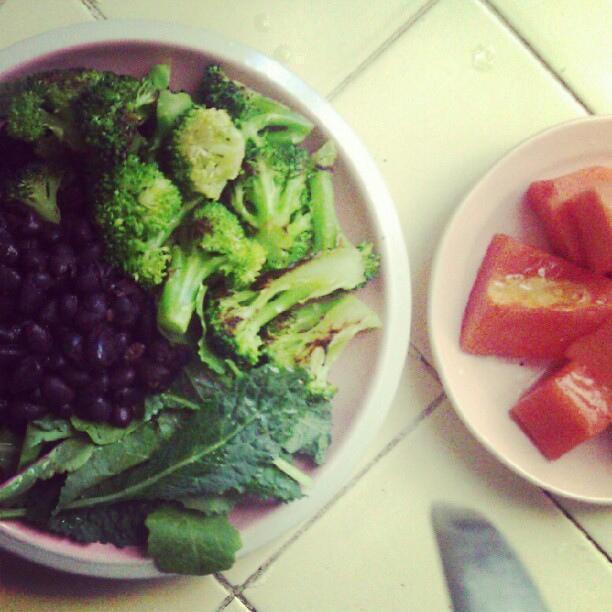Which item is likely most crispy?
Pick the right solution, then justify: 'Answer: answer
Rationale: rationale.'
Options: Black, lighter green, red, dark green. Answer: lighter green.
Rationale: The most crispy item is darker green. 